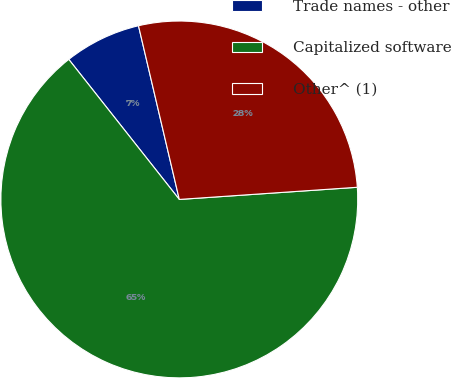<chart> <loc_0><loc_0><loc_500><loc_500><pie_chart><fcel>Trade names - other<fcel>Capitalized software<fcel>Other^ (1)<nl><fcel>6.96%<fcel>65.46%<fcel>27.59%<nl></chart> 